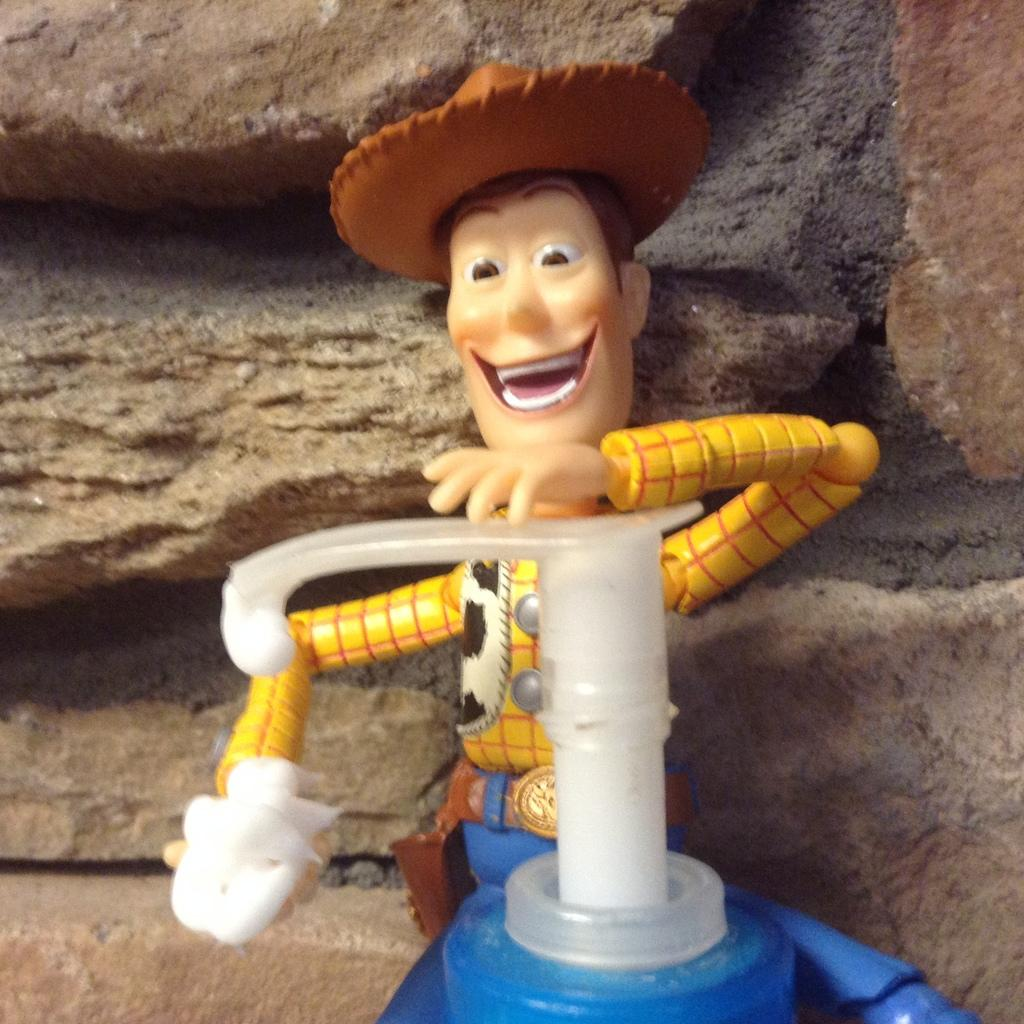What type of toy is in the image? The toy in the image resembles a spray bottle. What colors can be seen on the toy? The toy has a yellow shirt and a brown hat. What is visible in the background of the image? There are rocks in the background of the image. How does the toy measure the temperature of the rocks in the background? The toy does not have the ability to measure temperature, as it is a toy and not a temperature-sensing device. 